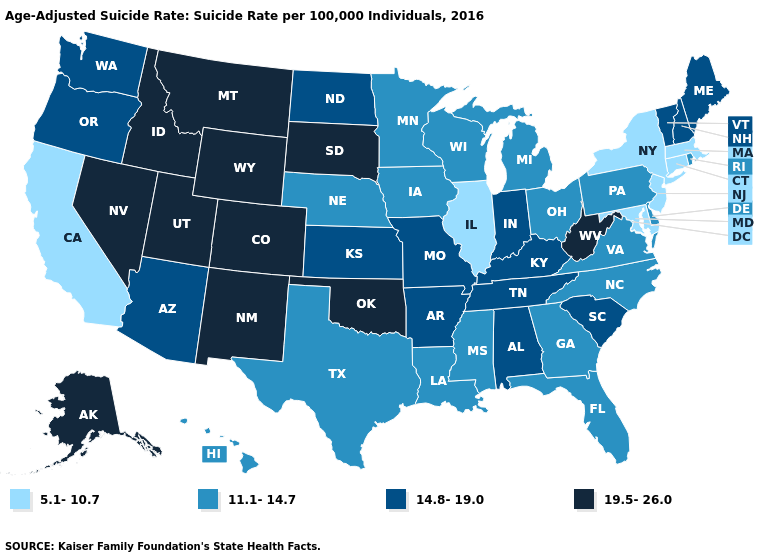Does the map have missing data?
Give a very brief answer. No. Does New Jersey have the lowest value in the Northeast?
Concise answer only. Yes. Among the states that border California , which have the lowest value?
Be succinct. Arizona, Oregon. What is the highest value in the MidWest ?
Quick response, please. 19.5-26.0. What is the lowest value in the USA?
Answer briefly. 5.1-10.7. What is the lowest value in the MidWest?
Be succinct. 5.1-10.7. What is the value of Florida?
Write a very short answer. 11.1-14.7. What is the lowest value in the USA?
Answer briefly. 5.1-10.7. Does Ohio have the highest value in the USA?
Give a very brief answer. No. Which states have the highest value in the USA?
Concise answer only. Alaska, Colorado, Idaho, Montana, Nevada, New Mexico, Oklahoma, South Dakota, Utah, West Virginia, Wyoming. What is the value of Missouri?
Be succinct. 14.8-19.0. Name the states that have a value in the range 19.5-26.0?
Concise answer only. Alaska, Colorado, Idaho, Montana, Nevada, New Mexico, Oklahoma, South Dakota, Utah, West Virginia, Wyoming. What is the value of Washington?
Concise answer only. 14.8-19.0. What is the value of Tennessee?
Short answer required. 14.8-19.0. 